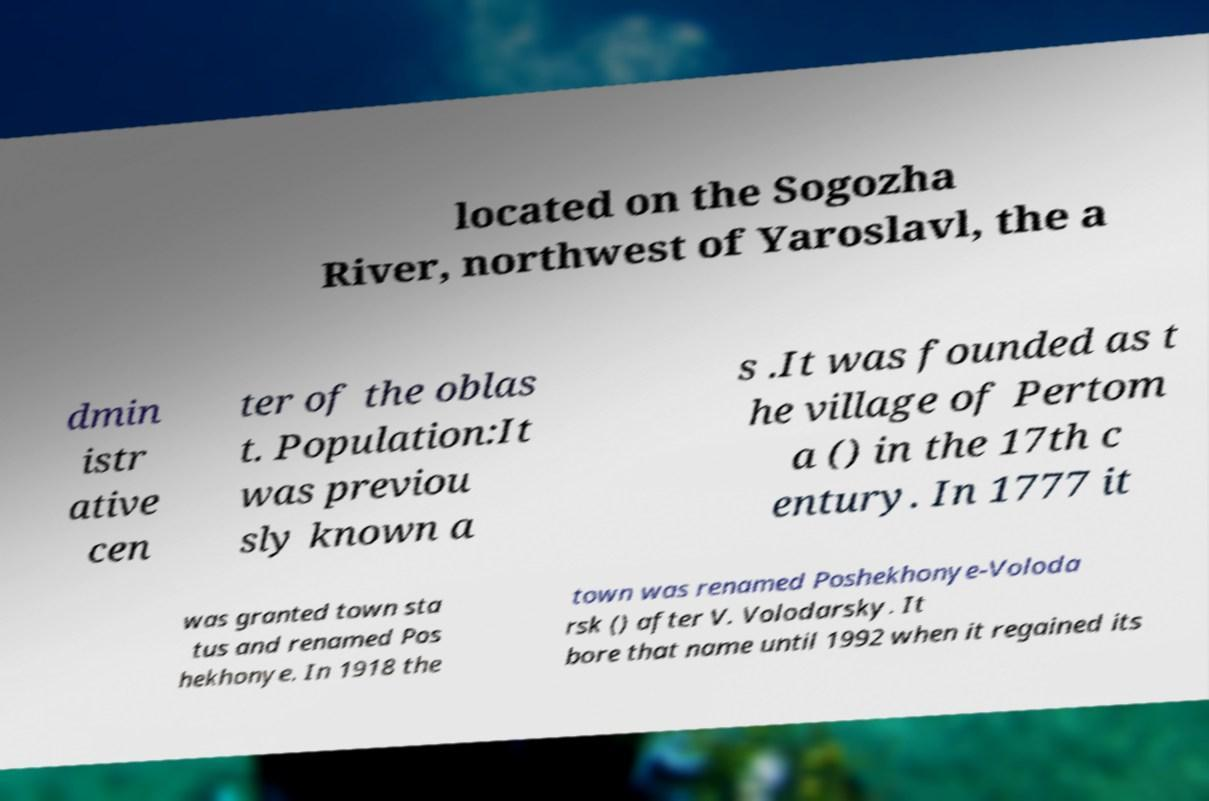Please identify and transcribe the text found in this image. located on the Sogozha River, northwest of Yaroslavl, the a dmin istr ative cen ter of the oblas t. Population:It was previou sly known a s .It was founded as t he village of Pertom a () in the 17th c entury. In 1777 it was granted town sta tus and renamed Pos hekhonye. In 1918 the town was renamed Poshekhonye-Voloda rsk () after V. Volodarsky. It bore that name until 1992 when it regained its 